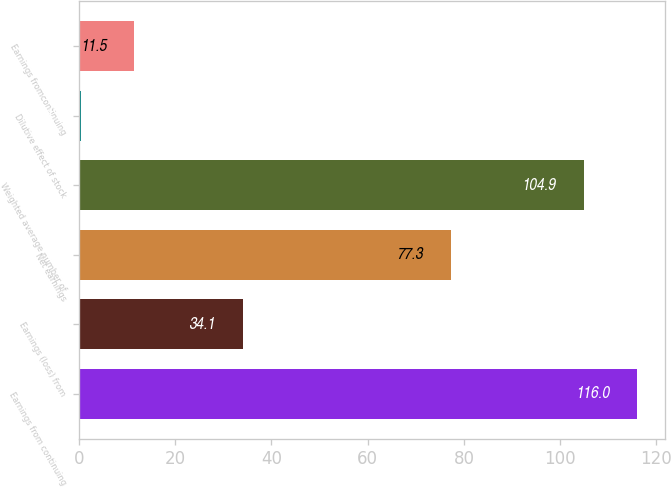Convert chart. <chart><loc_0><loc_0><loc_500><loc_500><bar_chart><fcel>Earnings from continuing<fcel>Earnings (loss) from<fcel>Net earnings<fcel>Weighted average number of<fcel>Dilutive effect of stock<fcel>Earnings fromcontinuing<nl><fcel>116<fcel>34.1<fcel>77.3<fcel>104.9<fcel>0.4<fcel>11.5<nl></chart> 